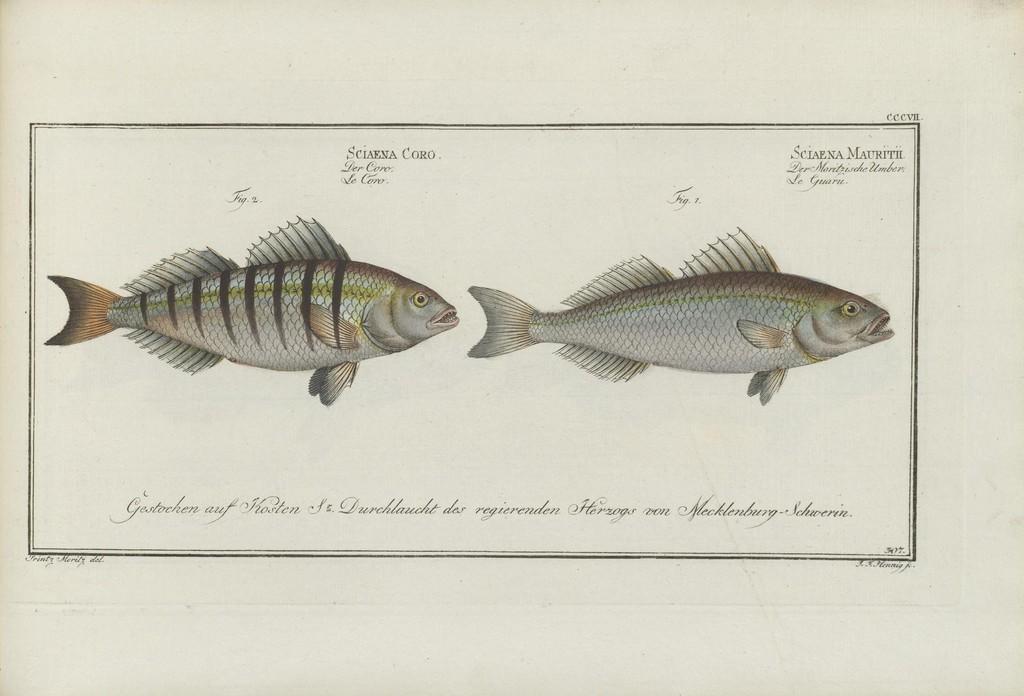Can you describe this image briefly? In this picture we can see depictions of fish and some information on a paper. 